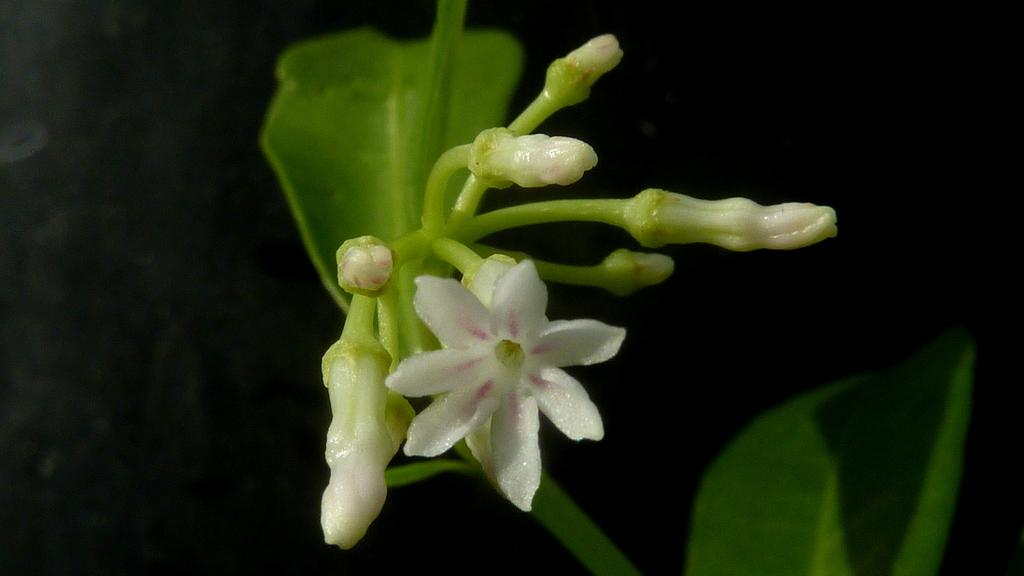What type of living organisms are present in the image? There are flowers in the image. Where are the flowers located? The flowers are on a plant. What colors can be seen in the flowers? The flowers are in white and pinkish colors. What is the color of the background in the image? The background of the image is black. Is it raining in the image? There is no indication of rain in the image; it only shows flowers on a plant with a black background. 